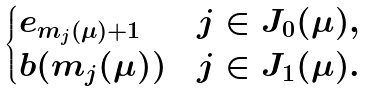<formula> <loc_0><loc_0><loc_500><loc_500>\begin{cases} e _ { m _ { j } ( \mu ) + 1 } & j \in J _ { 0 } ( \mu ) , \\ b ( m _ { j } ( \mu ) ) & j \in J _ { 1 } ( \mu ) . \end{cases}</formula> 